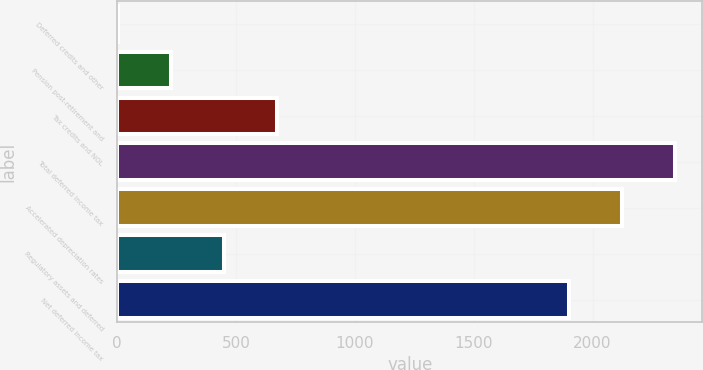Convert chart to OTSL. <chart><loc_0><loc_0><loc_500><loc_500><bar_chart><fcel>Deferred credits and other<fcel>Pension post-retirement and<fcel>Tax credits and NOL<fcel>Total deferred income tax<fcel>Accelerated depreciation rates<fcel>Regulatory assets and deferred<fcel>Net deferred income tax<nl><fcel>4<fcel>226.5<fcel>671.5<fcel>2345<fcel>2122.5<fcel>449<fcel>1900<nl></chart> 